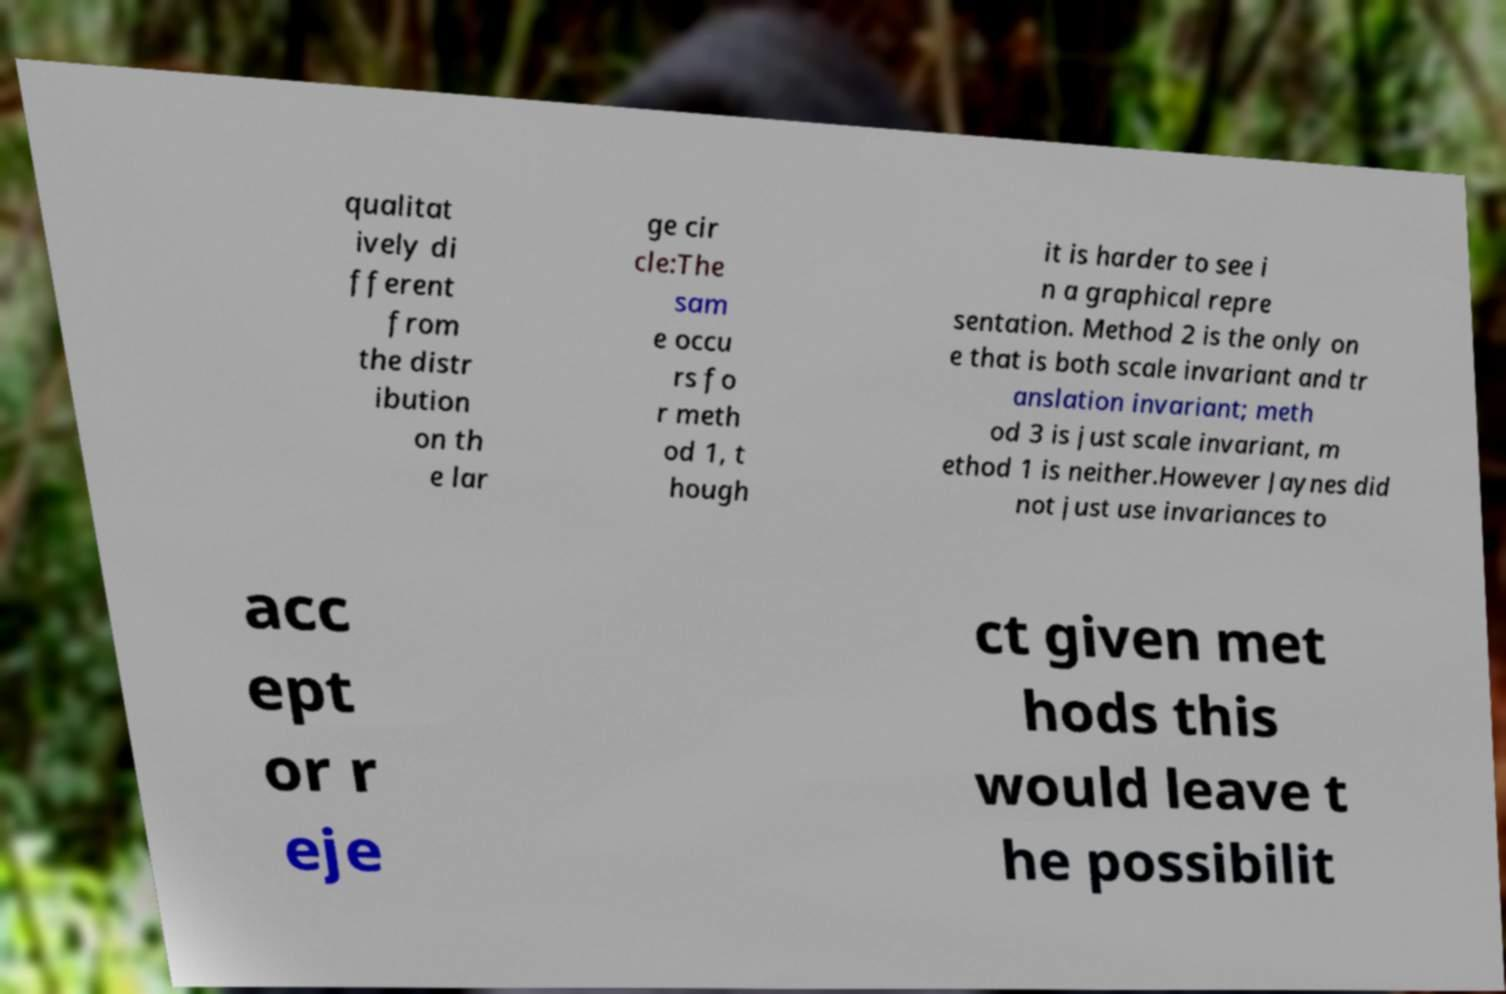Can you accurately transcribe the text from the provided image for me? qualitat ively di fferent from the distr ibution on th e lar ge cir cle:The sam e occu rs fo r meth od 1, t hough it is harder to see i n a graphical repre sentation. Method 2 is the only on e that is both scale invariant and tr anslation invariant; meth od 3 is just scale invariant, m ethod 1 is neither.However Jaynes did not just use invariances to acc ept or r eje ct given met hods this would leave t he possibilit 